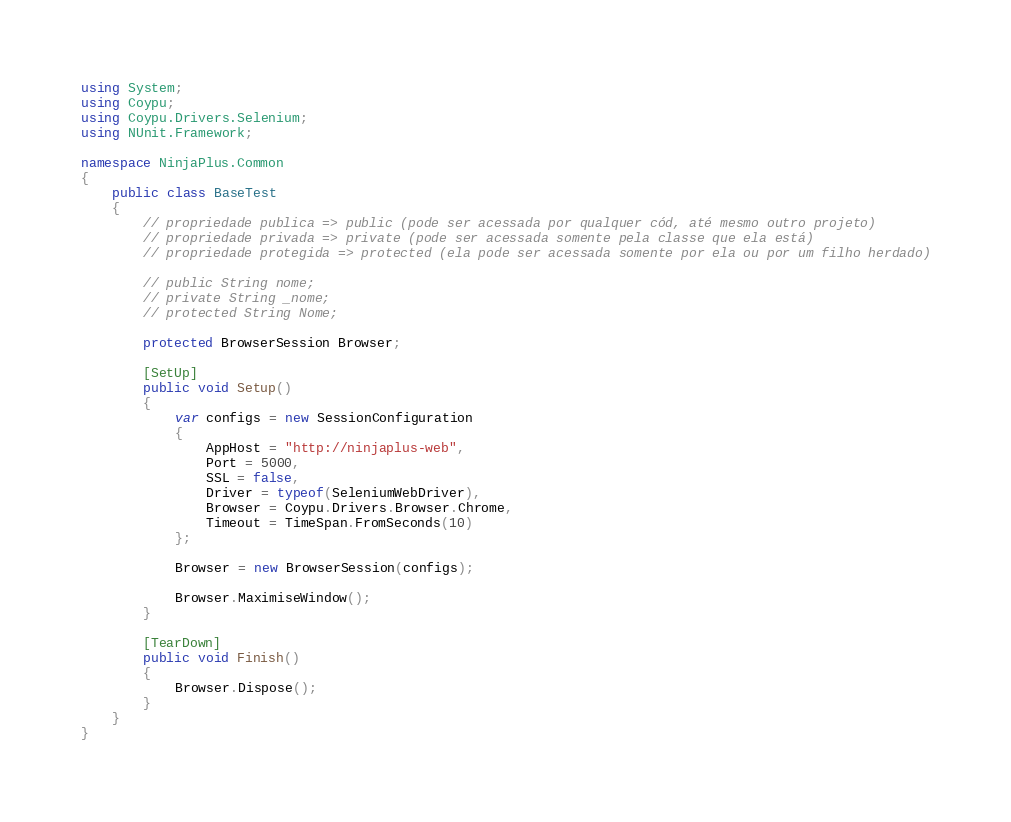<code> <loc_0><loc_0><loc_500><loc_500><_C#_>using System;
using Coypu;
using Coypu.Drivers.Selenium;
using NUnit.Framework;

namespace NinjaPlus.Common
{
    public class BaseTest
    {
        // propriedade publica => public (pode ser acessada por qualquer cód, até mesmo outro projeto)
        // propriedade privada => private (pode ser acessada somente pela classe que ela está)
        // propriedade protegida => protected (ela pode ser acessada somente por ela ou por um filho herdado)

        // public String nome;
        // private String _nome;
        // protected String Nome;

        protected BrowserSession Browser;
        
        [SetUp]
        public void Setup()
        {
            var configs = new SessionConfiguration
            {
                AppHost = "http://ninjaplus-web",
                Port = 5000,
                SSL = false,
                Driver = typeof(SeleniumWebDriver),
                Browser = Coypu.Drivers.Browser.Chrome,
                Timeout = TimeSpan.FromSeconds(10)
            };

            Browser = new BrowserSession(configs);
            
            Browser.MaximiseWindow();
        }

        [TearDown]
        public void Finish()
        {
            Browser.Dispose();
        }
    }
}</code> 